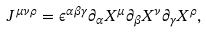Convert formula to latex. <formula><loc_0><loc_0><loc_500><loc_500>J ^ { \mu \nu \rho } = \epsilon ^ { \alpha \beta \gamma } \partial _ { \alpha } X ^ { \mu } \partial _ { \beta } X ^ { \nu } \partial _ { \gamma } X ^ { \rho } ,</formula> 